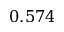Convert formula to latex. <formula><loc_0><loc_0><loc_500><loc_500>0 . 5 7 4</formula> 